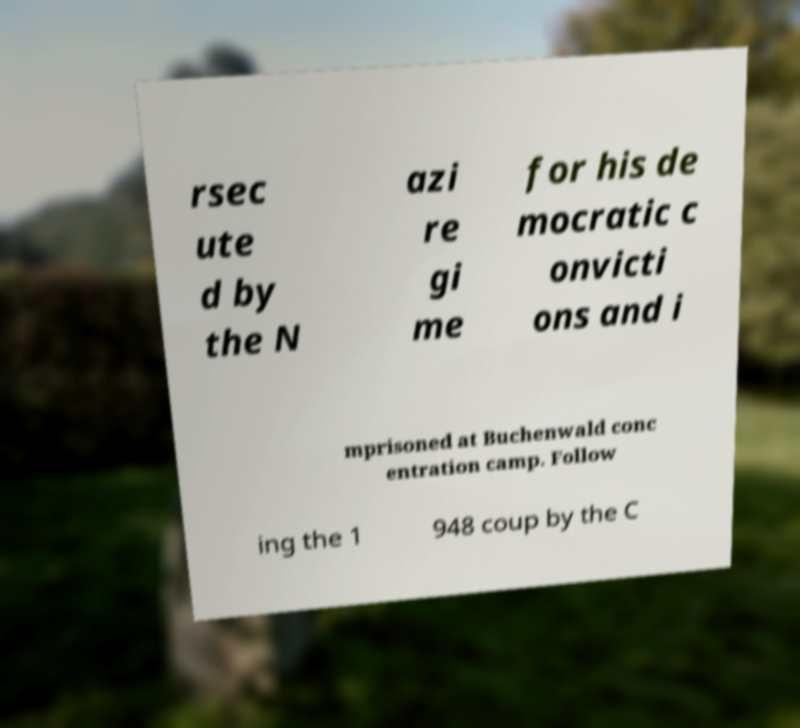Can you read and provide the text displayed in the image?This photo seems to have some interesting text. Can you extract and type it out for me? rsec ute d by the N azi re gi me for his de mocratic c onvicti ons and i mprisoned at Buchenwald conc entration camp. Follow ing the 1 948 coup by the C 